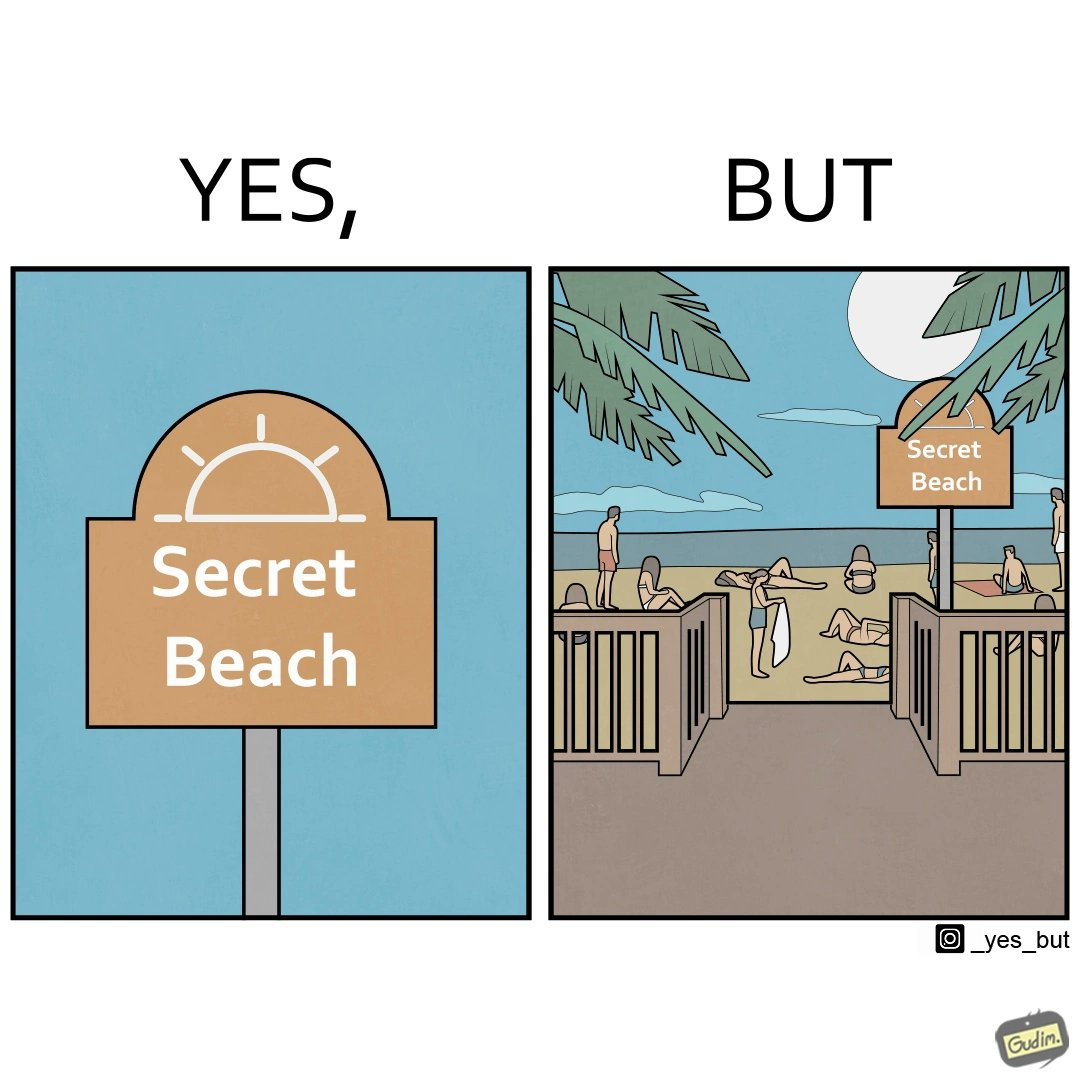Is this image satirical or non-satirical? Yes, this image is satirical. 